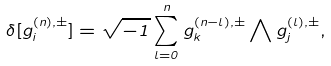Convert formula to latex. <formula><loc_0><loc_0><loc_500><loc_500>\delta [ g _ { i } ^ { ( n ) , \pm } ] = \sqrt { - 1 } \sum _ { l = 0 } ^ { n } g _ { k } ^ { ( n - l ) , \pm } \bigwedge g _ { j } ^ { ( l ) , \pm } ,</formula> 